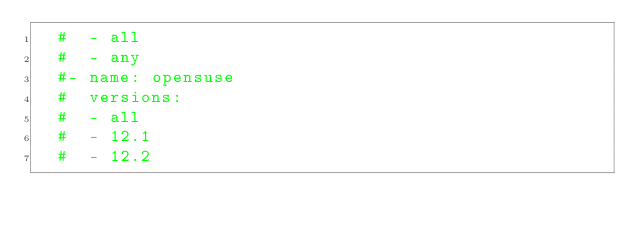<code> <loc_0><loc_0><loc_500><loc_500><_YAML_>  #  - all
  #  - any
  #- name: opensuse
  #  versions:
  #  - all
  #  - 12.1
  #  - 12.2</code> 